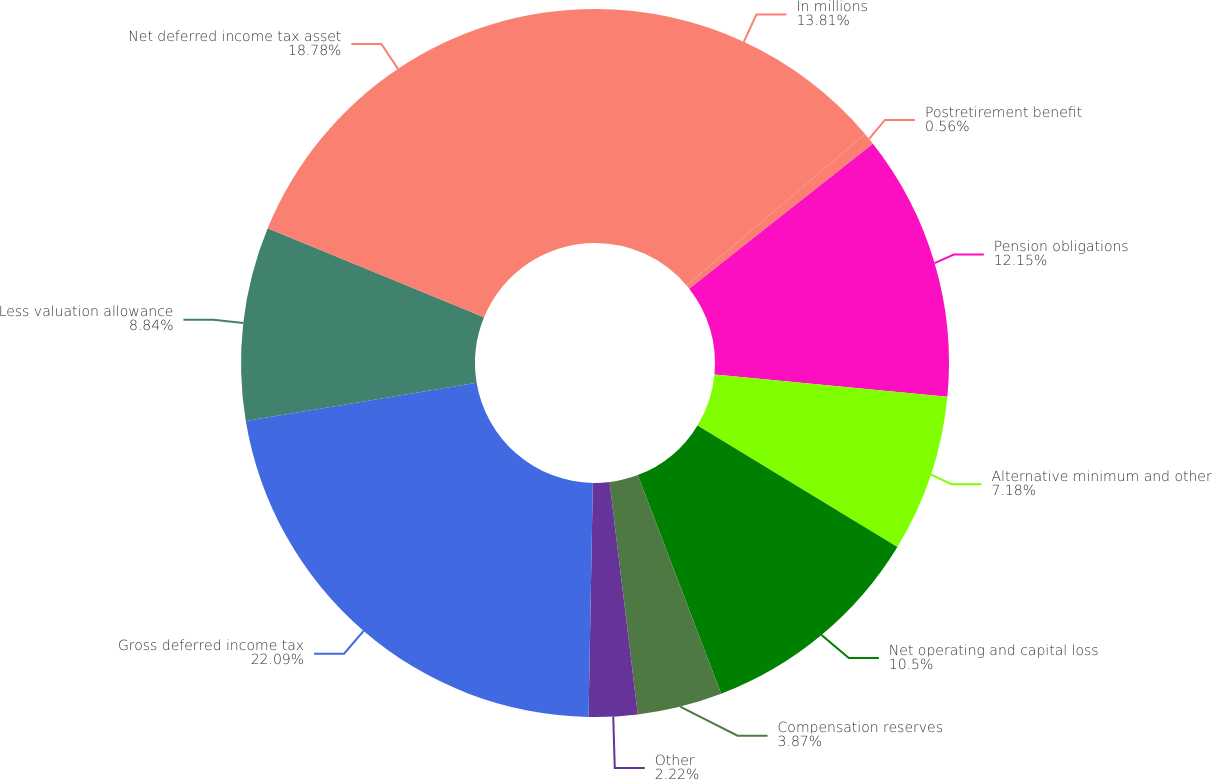<chart> <loc_0><loc_0><loc_500><loc_500><pie_chart><fcel>In millions<fcel>Postretirement benefit<fcel>Pension obligations<fcel>Alternative minimum and other<fcel>Net operating and capital loss<fcel>Compensation reserves<fcel>Other<fcel>Gross deferred income tax<fcel>Less valuation allowance<fcel>Net deferred income tax asset<nl><fcel>13.81%<fcel>0.56%<fcel>12.15%<fcel>7.18%<fcel>10.5%<fcel>3.87%<fcel>2.22%<fcel>22.09%<fcel>8.84%<fcel>18.78%<nl></chart> 